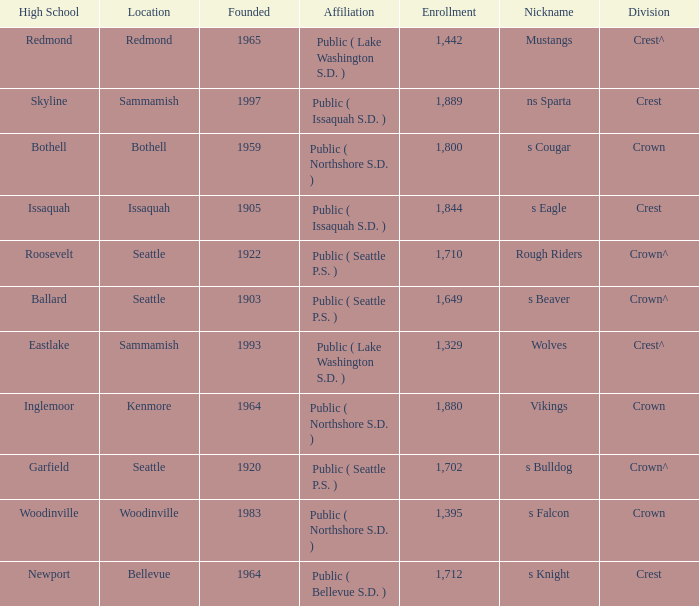What is the affiliation of a high school in Issaquah that was founded in less than 1965? Public ( Issaquah S.D. ). 